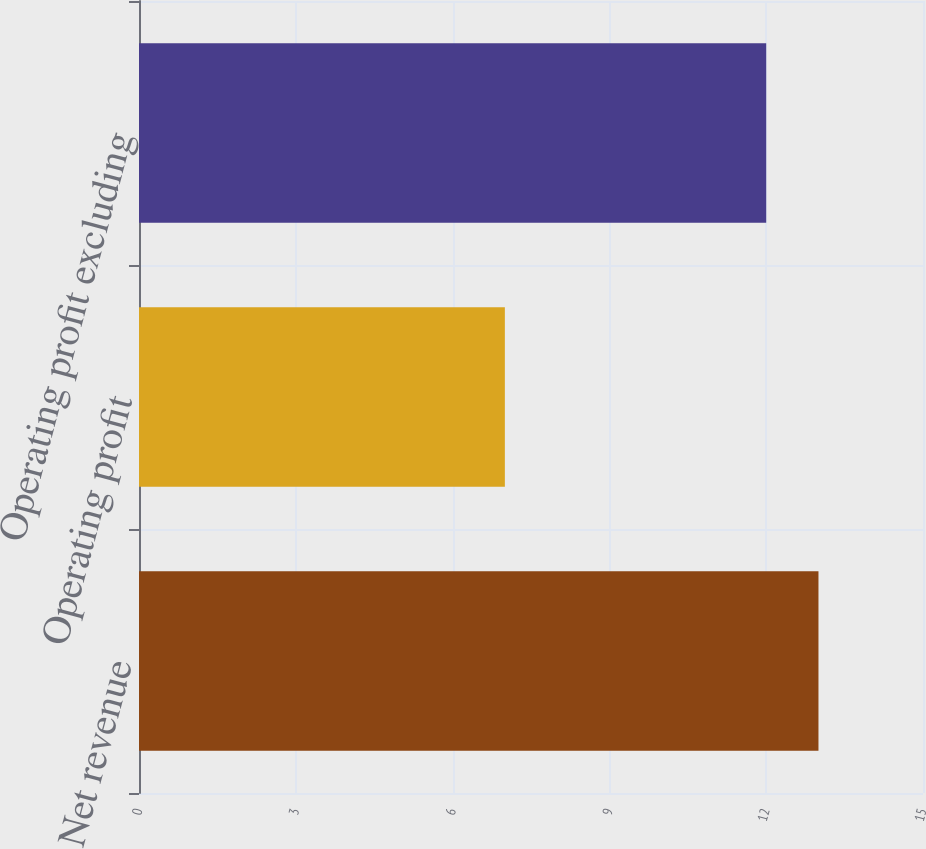<chart> <loc_0><loc_0><loc_500><loc_500><bar_chart><fcel>Net revenue<fcel>Operating profit<fcel>Operating profit excluding<nl><fcel>13<fcel>7<fcel>12<nl></chart> 